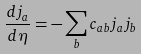<formula> <loc_0><loc_0><loc_500><loc_500>\frac { d j _ { a } } { d \eta } = - \sum _ { b } c _ { a b } j _ { a } j _ { b }</formula> 